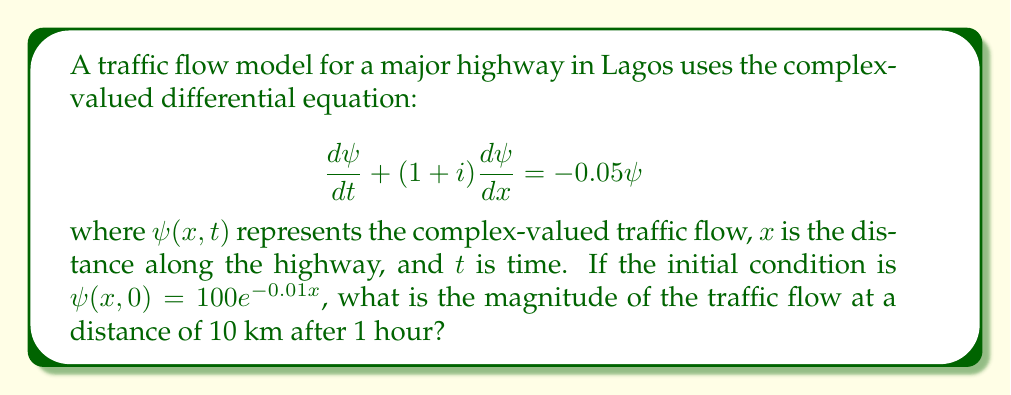Give your solution to this math problem. To solve this problem, we'll follow these steps:

1) The given equation is a first-order partial differential equation. Its general solution is of the form:

   $$\psi(x,t) = f(x-(1+i)t)e^{-0.05t}$$

   where $f$ is a function determined by the initial condition.

2) From the initial condition, we have:

   $$\psi(x,0) = 100e^{-0.01x} = f(x)$$

3) Therefore, the complete solution is:

   $$\psi(x,t) = 100e^{-0.01(x-(1+i)t)}e^{-0.05t}$$

4) We need to evaluate this at $x=10$ (10 km) and $t=1$ (1 hour):

   $$\psi(10,1) = 100e^{-0.01(10-(1+i))}e^{-0.05}$$

5) Simplifying:

   $$\psi(10,1) = 100e^{-0.1+0.01(1+i)}e^{-0.05}$$
   $$= 100e^{-0.14+0.01i}$$

6) To find the magnitude, we use $|\psi| = \sqrt{\text{Re}(\psi)^2 + \text{Im}(\psi)^2}$:

   $$|\psi(10,1)| = 100|e^{-0.14+0.01i}| = 100e^{-0.14}$$

7) Calculating this value:

   $$|\psi(10,1)| = 100 \cdot 0.8695 = 86.95$$
Answer: 86.95 